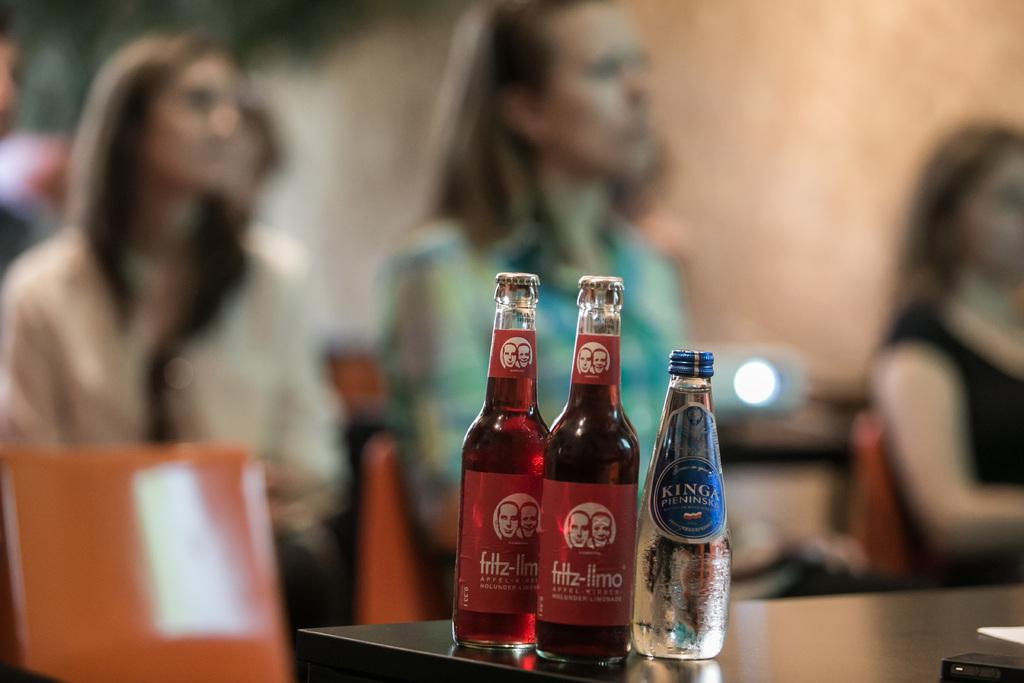What are the girls in the image doing? The girls are sitting on chairs in the image. What is in front of the chairs? There is a table in front of the chairs. What can be seen on the table? There are three bottles on the table. What type of ear is visible on the table in the image? There is no ear present on the table in the image. Can you tell me how many crackers are on the table in the image? There is no mention of crackers in the image; only three bottles are visible on the table. 